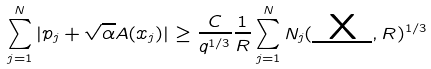<formula> <loc_0><loc_0><loc_500><loc_500>\sum _ { j = 1 } ^ { N } | p _ { j } + \sqrt { \alpha } A ( x _ { j } ) | \geq \frac { C } { q ^ { 1 / 3 } } \frac { 1 } { R } \sum ^ { N } _ { j = 1 } N _ { j } ( \underbar { X } , R ) ^ { 1 / 3 }</formula> 